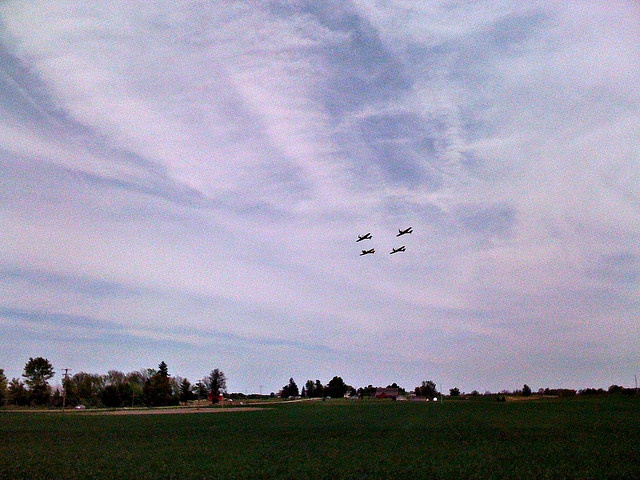Describe the objects in this image and their specific colors. I can see airplane in darkgray, black, lavender, and gray tones, airplane in darkgray, black, lavender, and gray tones, airplane in darkgray, black, lavender, and gray tones, airplane in darkgray, black, and gray tones, and car in darkgray, gray, black, and maroon tones in this image. 